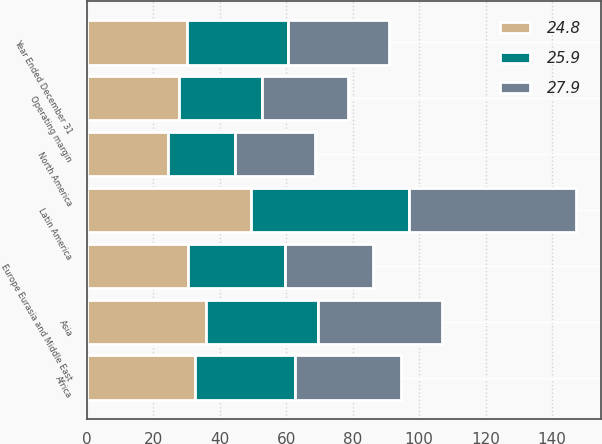Convert chart to OTSL. <chart><loc_0><loc_0><loc_500><loc_500><stacked_bar_chart><ecel><fcel>Year Ended December 31<fcel>North America<fcel>Africa<fcel>Asia<fcel>Europe Eurasia and Middle East<fcel>Latin America<fcel>Operating margin<nl><fcel>27.9<fcel>30.35<fcel>24.2<fcel>31.9<fcel>37.5<fcel>26.4<fcel>50.4<fcel>25.9<nl><fcel>25.9<fcel>30.35<fcel>20.2<fcel>30.1<fcel>33.5<fcel>29.1<fcel>47.5<fcel>24.8<nl><fcel>24.8<fcel>30.35<fcel>24.4<fcel>32.7<fcel>36<fcel>30.6<fcel>49.4<fcel>27.9<nl></chart> 